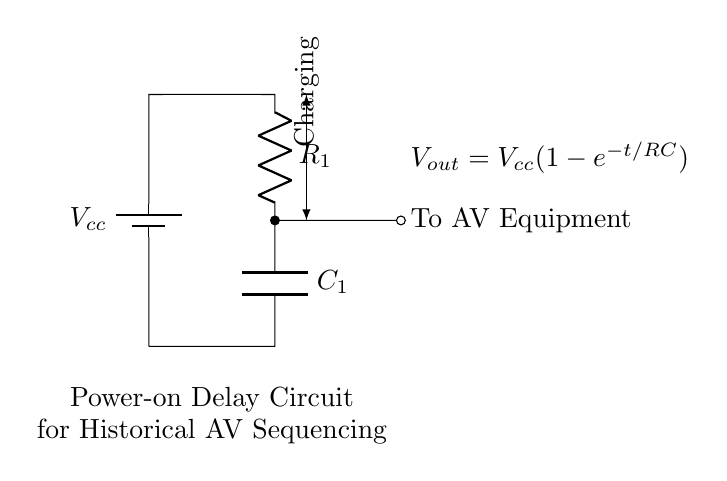What type of circuit is shown? The circuit is an RC (Resistor-Capacitor) circuit, designed to provide a power-on delay functionality by using a resistor and capacitor in series.
Answer: RC circuit What does R represent in this circuit? R represents the resistor (R1) used to limit the charging current flowing into the capacitor, which determines the time constant of the circuit.
Answer: Resistor What is the function of C in this circuit? C is the capacitor (C1), which stores electrical energy and influences the delay time of the power-on sequencing in conjunction with the resistor.
Answer: Capacitor What is the output equation represented in the circuit? The output equation shown in the circuit is Vout = Vcc(1 - e^(-t/RC)), indicating how the output voltage varies over time as the capacitor charges through the resistor.
Answer: Vout = Vcc(1 - e^(-t/RC)) How does the circuit achieve a power-on delay? The circuit achieves a power-on delay by initially charging the capacitor through the resistor, which takes time based on the RC time constant, thus delaying the voltage output to the AV equipment.
Answer: By charging the capacitor What is the significance of the time constant in this circuit? The time constant (τ = RC) defines the time it takes for the capacitor to charge to approximately 63.2% of Vcc, directly influencing the delay duration before reaching the output voltage level.
Answer: RC time constant What happens to Vout when t approaches infinity? As time t approaches infinity, the capacitor fully charges to Vcc, and Vout will equal Vcc, meaning the output voltage reaches its maximum steady state.
Answer: Vout = Vcc 